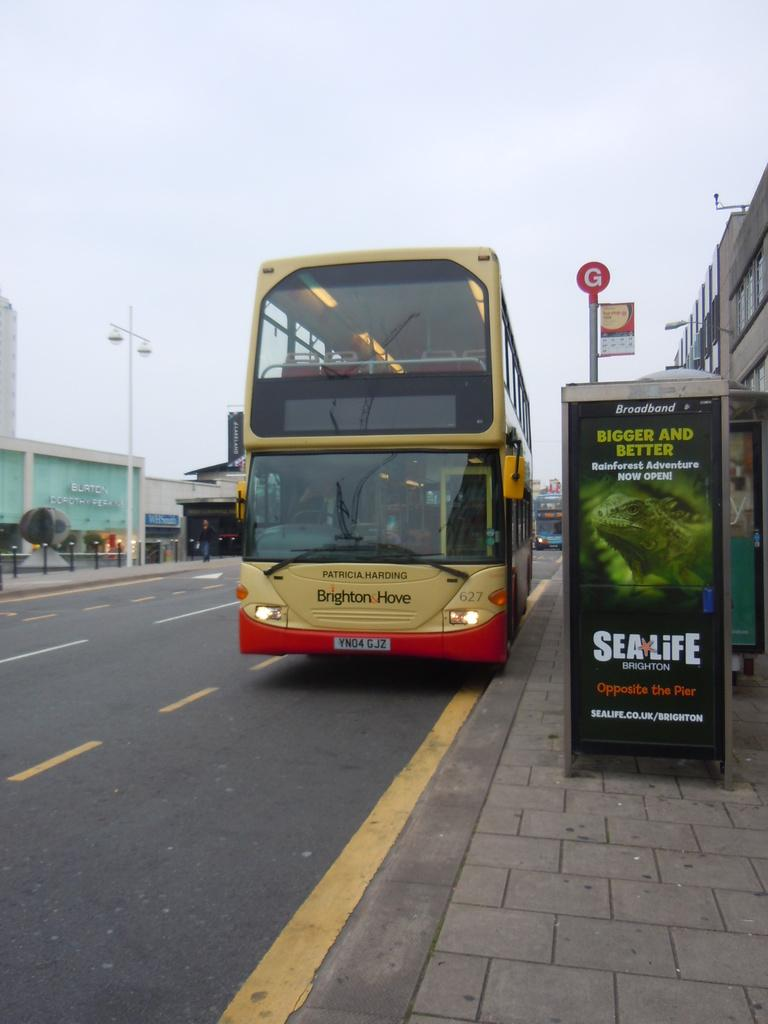What is the main subject of the image? The main subject of the image is a bus. What else can be seen in the image besides the bus? There is a banner, buildings, street lamps, and lights visible in the image. What is visible at the top of the image? The sky is visible at the top of the image. Where is the market located in the image? There is no market present in the image. What type of cent can be seen in the image? There is no mention of a cent or any currency in the image. 